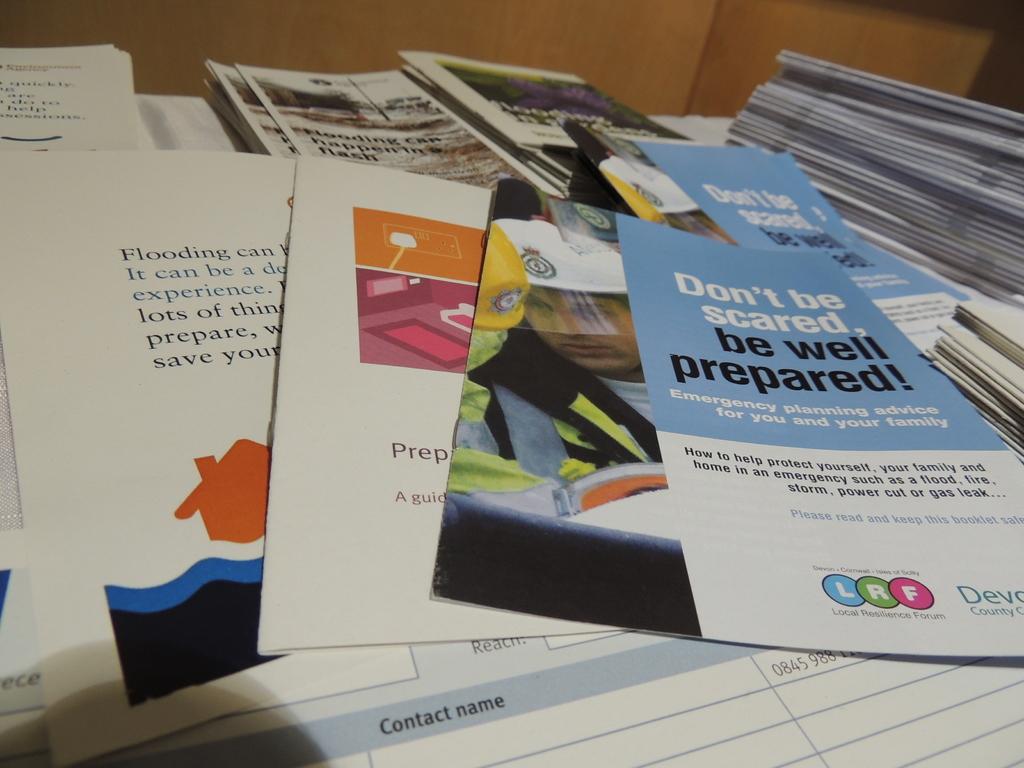Who prepared the top pamphlet?
Offer a terse response. Unanswerable. What kind of advice is given in the blue and white pamphlet?
Your answer should be very brief. Don't be scared, be well prepared!. 